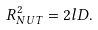Convert formula to latex. <formula><loc_0><loc_0><loc_500><loc_500>R _ { N U T } ^ { 2 } = 2 l D .</formula> 